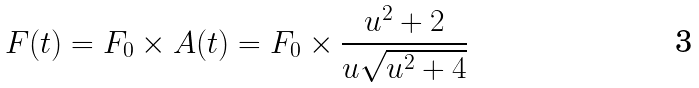Convert formula to latex. <formula><loc_0><loc_0><loc_500><loc_500>F ( t ) = F _ { 0 } \times A ( t ) = F _ { 0 } \times \frac { u ^ { 2 } + 2 } { u \sqrt { u ^ { 2 } + 4 } }</formula> 